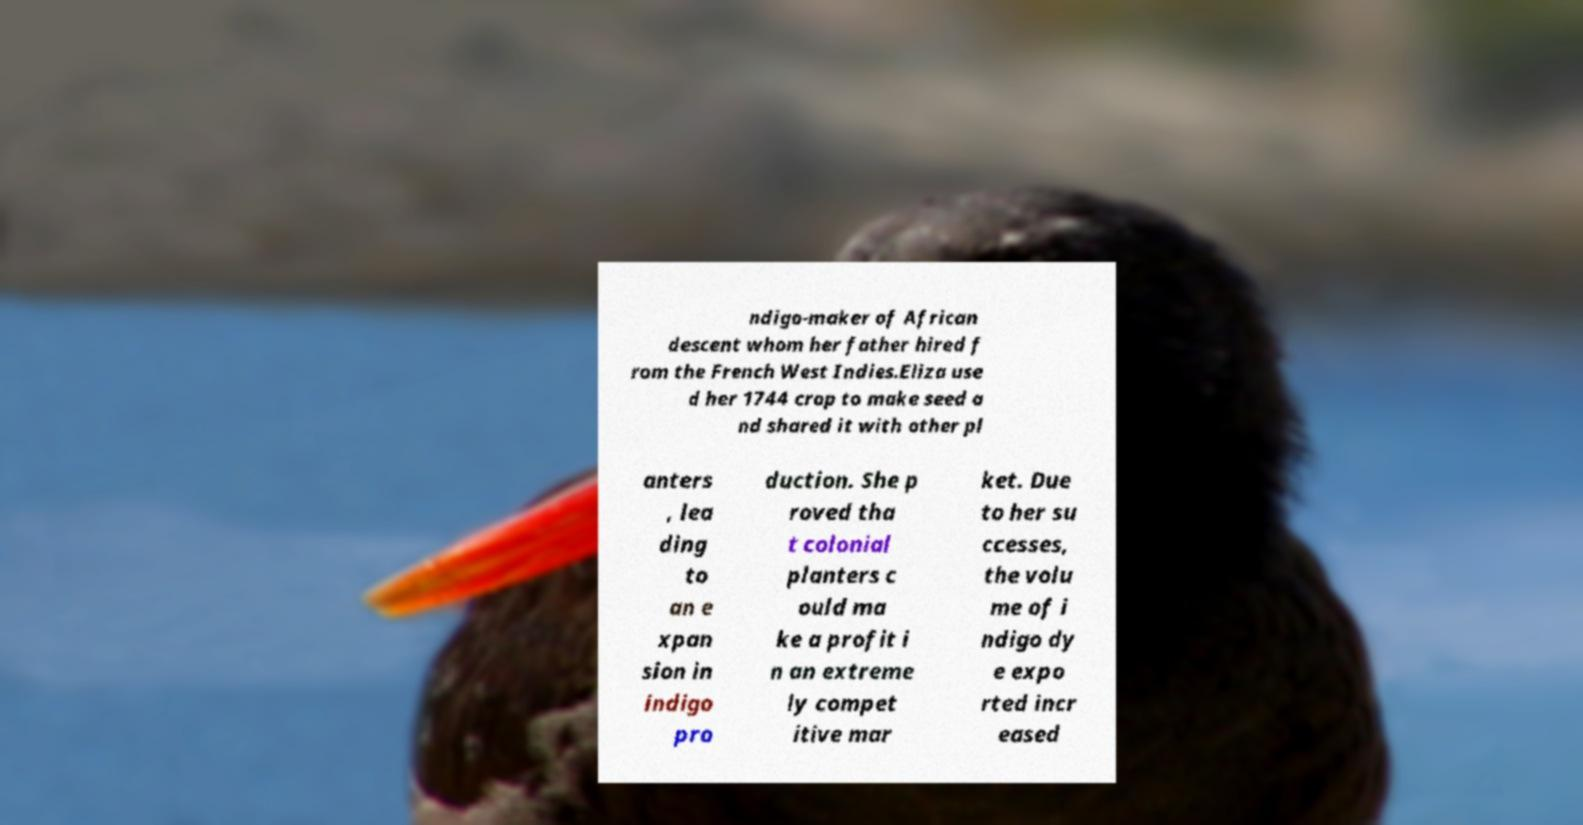Please read and relay the text visible in this image. What does it say? ndigo-maker of African descent whom her father hired f rom the French West Indies.Eliza use d her 1744 crop to make seed a nd shared it with other pl anters , lea ding to an e xpan sion in indigo pro duction. She p roved tha t colonial planters c ould ma ke a profit i n an extreme ly compet itive mar ket. Due to her su ccesses, the volu me of i ndigo dy e expo rted incr eased 